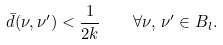Convert formula to latex. <formula><loc_0><loc_0><loc_500><loc_500>\bar { d } ( \nu , \nu ^ { \prime } ) < \frac { 1 } { 2 k } \quad \forall \nu , \, \nu ^ { \prime } \in B _ { l } .</formula> 